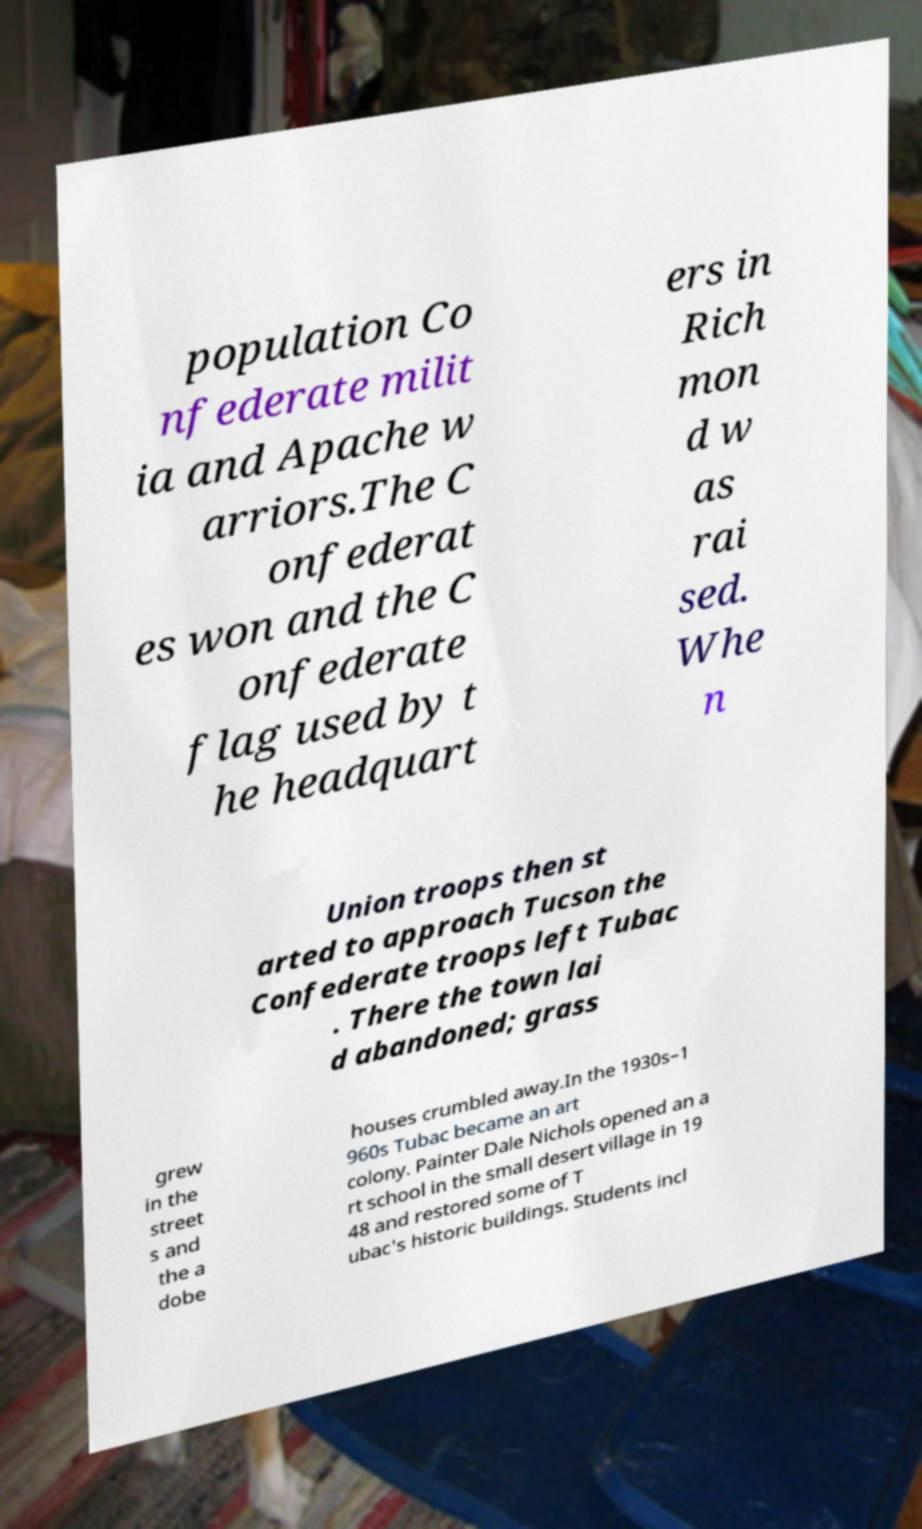Could you assist in decoding the text presented in this image and type it out clearly? population Co nfederate milit ia and Apache w arriors.The C onfederat es won and the C onfederate flag used by t he headquart ers in Rich mon d w as rai sed. Whe n Union troops then st arted to approach Tucson the Confederate troops left Tubac . There the town lai d abandoned; grass grew in the street s and the a dobe houses crumbled away.In the 1930s–1 960s Tubac became an art colony. Painter Dale Nichols opened an a rt school in the small desert village in 19 48 and restored some of T ubac's historic buildings. Students incl 